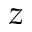Convert formula to latex. <formula><loc_0><loc_0><loc_500><loc_500>z</formula> 